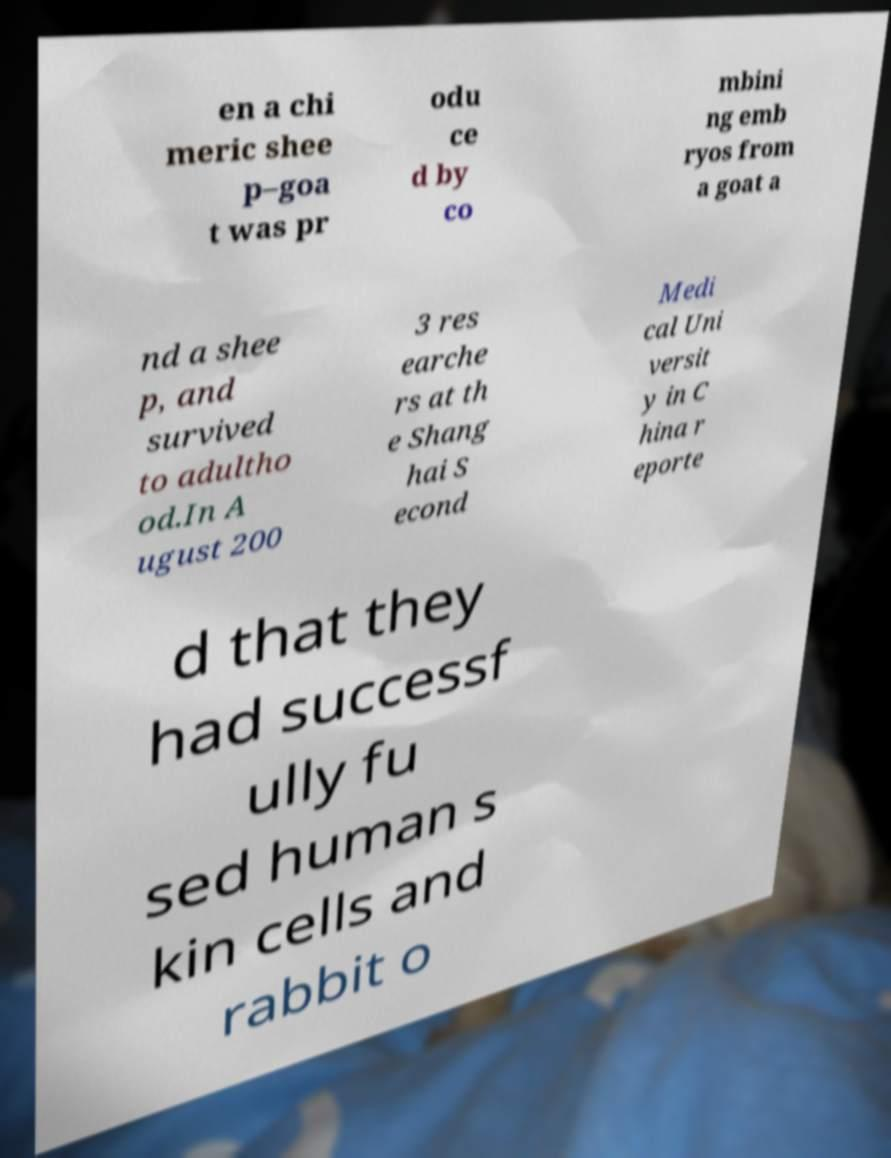Could you extract and type out the text from this image? en a chi meric shee p–goa t was pr odu ce d by co mbini ng emb ryos from a goat a nd a shee p, and survived to adultho od.In A ugust 200 3 res earche rs at th e Shang hai S econd Medi cal Uni versit y in C hina r eporte d that they had successf ully fu sed human s kin cells and rabbit o 